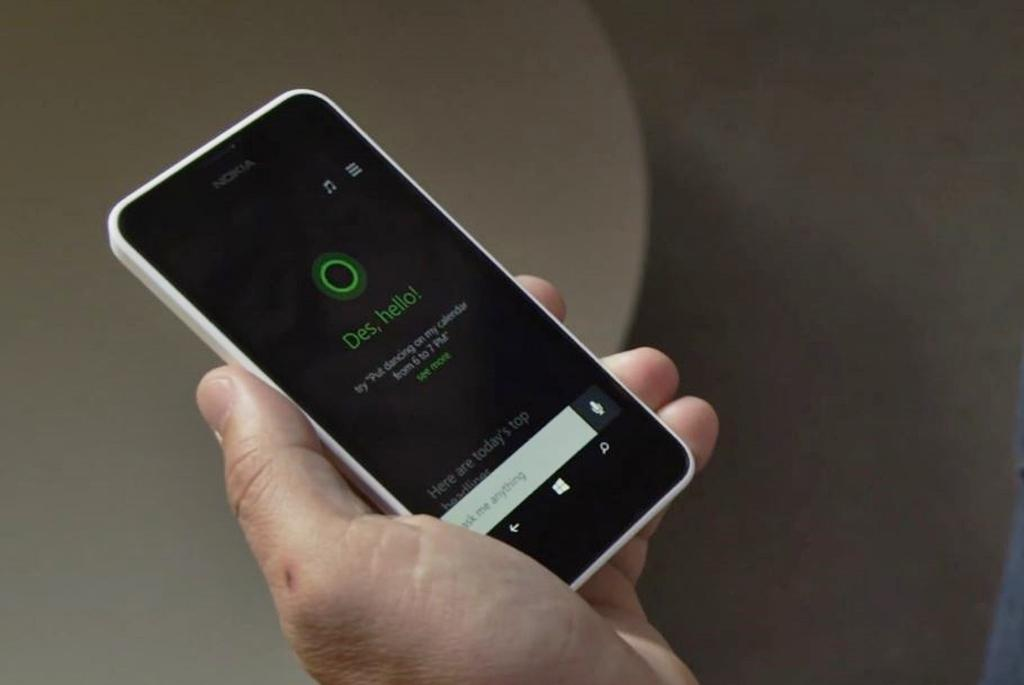<image>
Write a terse but informative summary of the picture. A Nokia cell phone has green letters that spells out Des, Hello. 